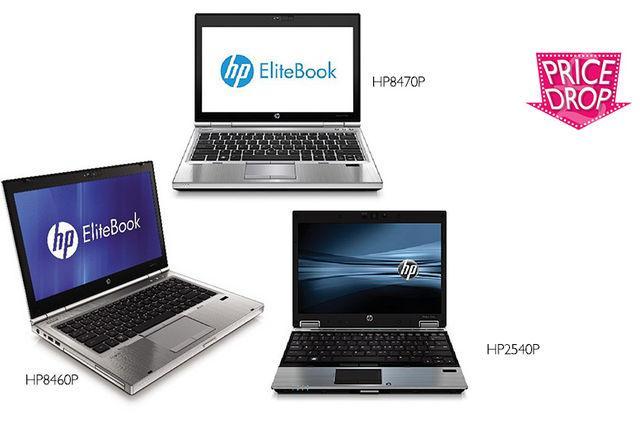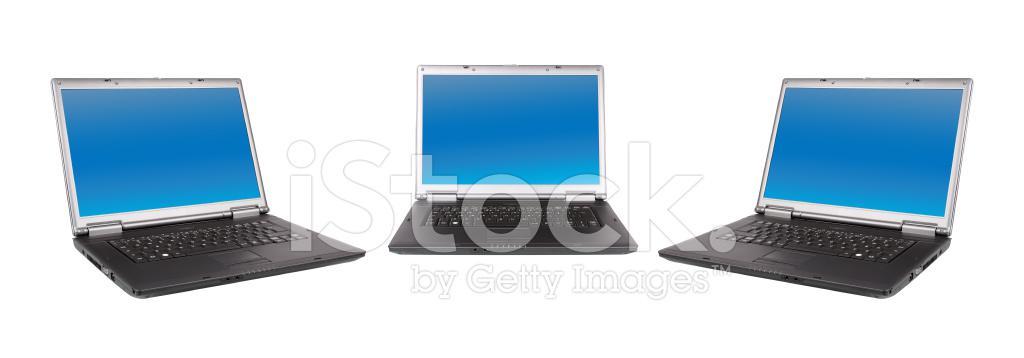The first image is the image on the left, the second image is the image on the right. Examine the images to the left and right. Is the description "Exactly three computers are shown in the left image and all three computers are open with a design shown on the screen." accurate? Answer yes or no. Yes. The first image is the image on the left, the second image is the image on the right. For the images displayed, is the sentence "There are three laptops in at least one of the images." factually correct? Answer yes or no. Yes. 